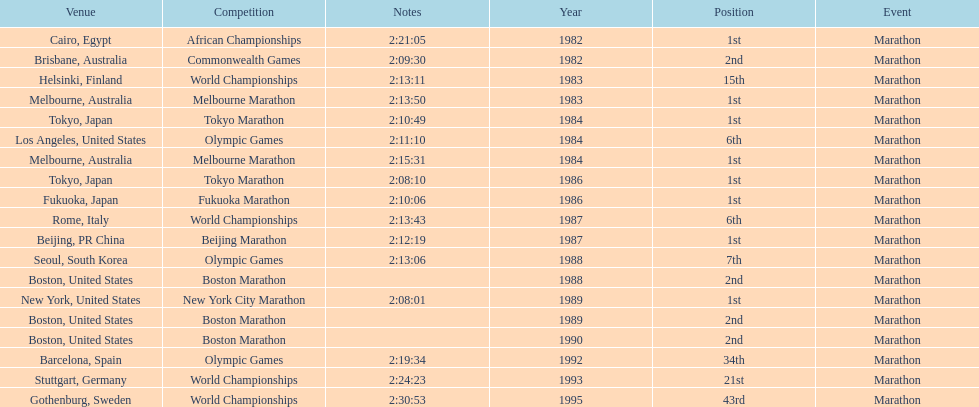In what year did the runner participate in the most marathons? 1984. 